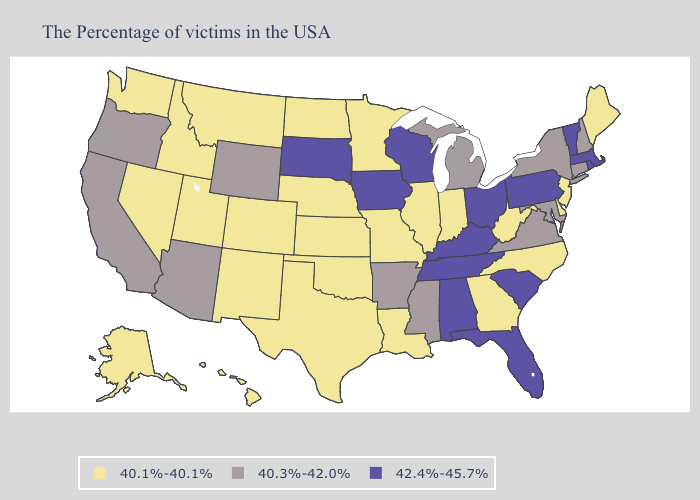Name the states that have a value in the range 40.3%-42.0%?
Short answer required. New Hampshire, Connecticut, New York, Maryland, Virginia, Michigan, Mississippi, Arkansas, Wyoming, Arizona, California, Oregon. Does Pennsylvania have the lowest value in the Northeast?
Concise answer only. No. Which states hav the highest value in the South?
Concise answer only. South Carolina, Florida, Kentucky, Alabama, Tennessee. Name the states that have a value in the range 42.4%-45.7%?
Write a very short answer. Massachusetts, Rhode Island, Vermont, Pennsylvania, South Carolina, Ohio, Florida, Kentucky, Alabama, Tennessee, Wisconsin, Iowa, South Dakota. Among the states that border New York , which have the highest value?
Quick response, please. Massachusetts, Vermont, Pennsylvania. What is the value of Idaho?
Quick response, please. 40.1%-40.1%. Does Georgia have a higher value than Nebraska?
Answer briefly. No. What is the value of Rhode Island?
Concise answer only. 42.4%-45.7%. Which states have the lowest value in the MidWest?
Be succinct. Indiana, Illinois, Missouri, Minnesota, Kansas, Nebraska, North Dakota. Does the first symbol in the legend represent the smallest category?
Answer briefly. Yes. Does the map have missing data?
Keep it brief. No. What is the value of Oregon?
Keep it brief. 40.3%-42.0%. Among the states that border Ohio , which have the lowest value?
Be succinct. West Virginia, Indiana. Among the states that border North Carolina , does Virginia have the highest value?
Give a very brief answer. No. 